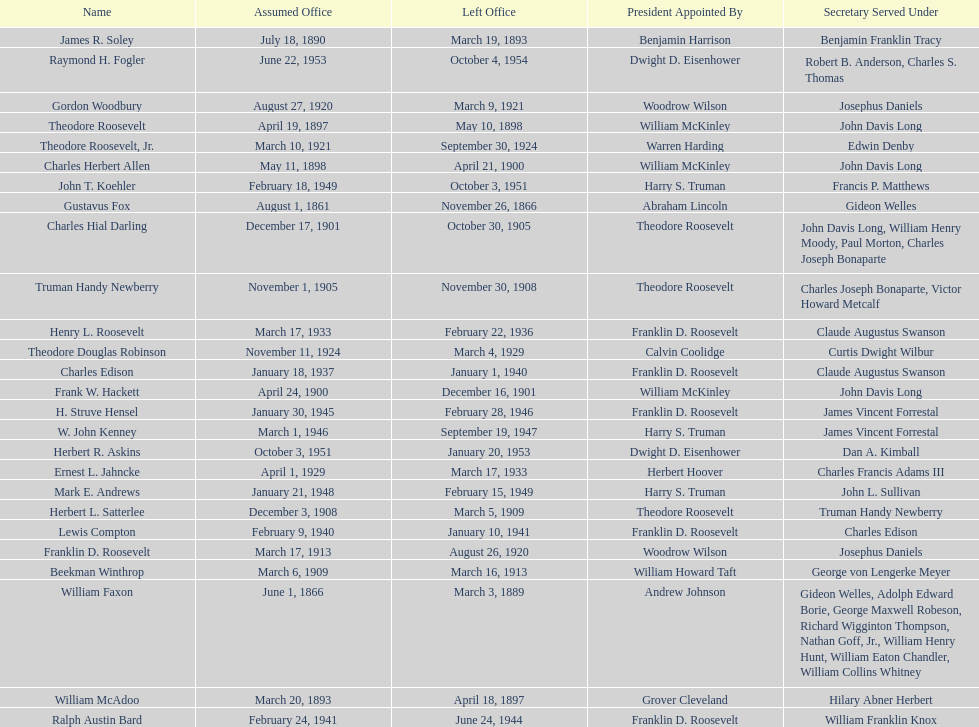When did raymond h. fogler leave the office of assistant secretary of the navy? October 4, 1954. 